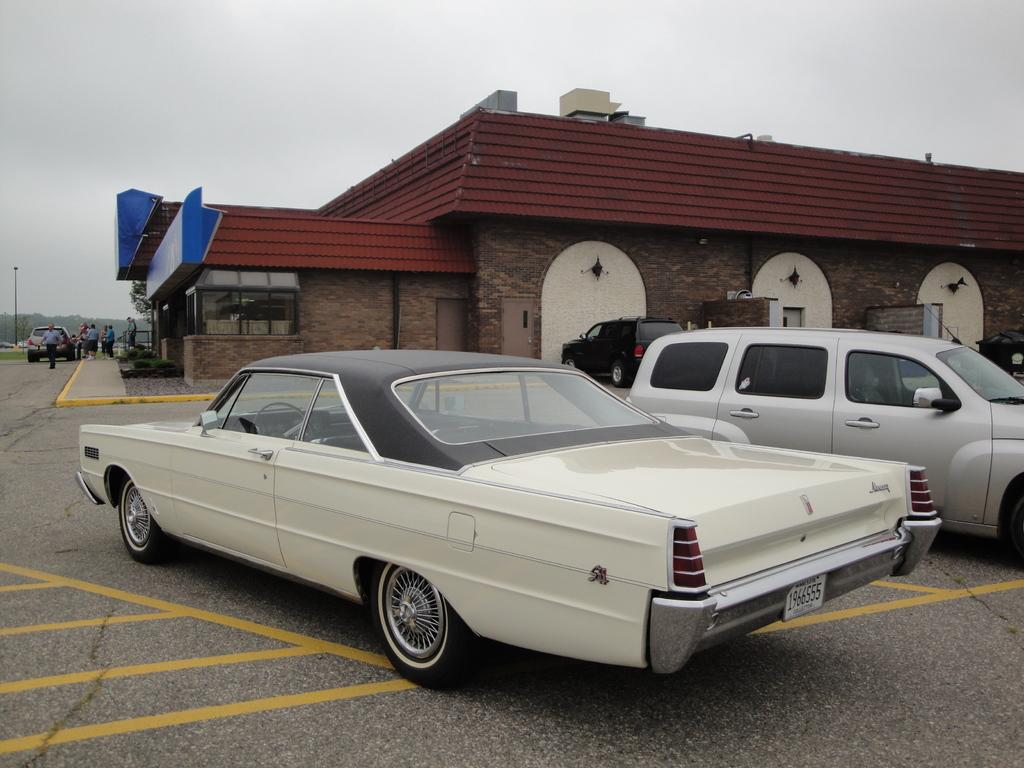What can be seen on the road in the image? There are vehicles on the road in the image. What else is visible in the background of the image? There are persons, at least one vehicle, a building, and trees in the background. What is visible in the sky in the image? There are clouds in the sky in the image. What type of chair is being rewarded for its factual knowledge in the image? There is no chair or reward present in the image. 